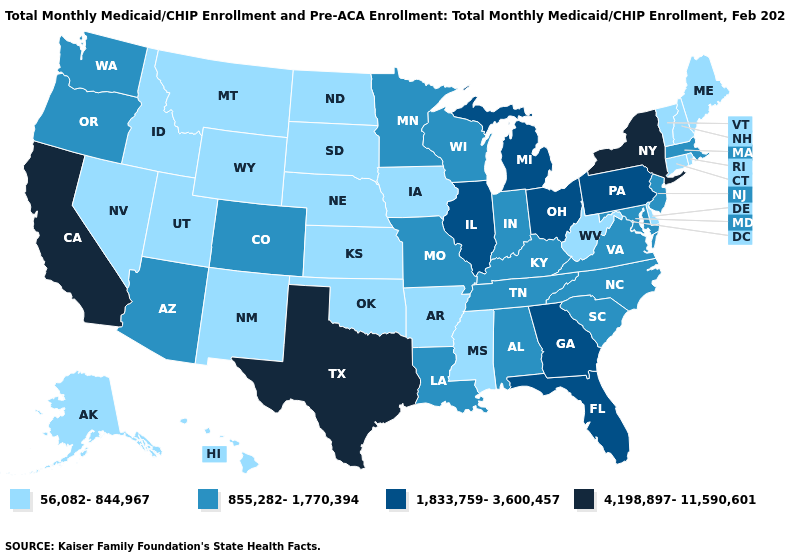Name the states that have a value in the range 4,198,897-11,590,601?
Give a very brief answer. California, New York, Texas. What is the highest value in the Northeast ?
Write a very short answer. 4,198,897-11,590,601. What is the value of Delaware?
Concise answer only. 56,082-844,967. Which states have the highest value in the USA?
Write a very short answer. California, New York, Texas. What is the lowest value in states that border Maine?
Short answer required. 56,082-844,967. What is the value of Kansas?
Short answer required. 56,082-844,967. Among the states that border Arizona , does Colorado have the lowest value?
Be succinct. No. Does West Virginia have the lowest value in the USA?
Quick response, please. Yes. What is the value of Oklahoma?
Keep it brief. 56,082-844,967. Does Maine have a higher value than Illinois?
Answer briefly. No. Name the states that have a value in the range 4,198,897-11,590,601?
Write a very short answer. California, New York, Texas. What is the lowest value in the USA?
Give a very brief answer. 56,082-844,967. What is the lowest value in states that border Alabama?
Short answer required. 56,082-844,967. Among the states that border Arkansas , does Tennessee have the lowest value?
Answer briefly. No. Among the states that border Oklahoma , does Arkansas have the lowest value?
Give a very brief answer. Yes. 